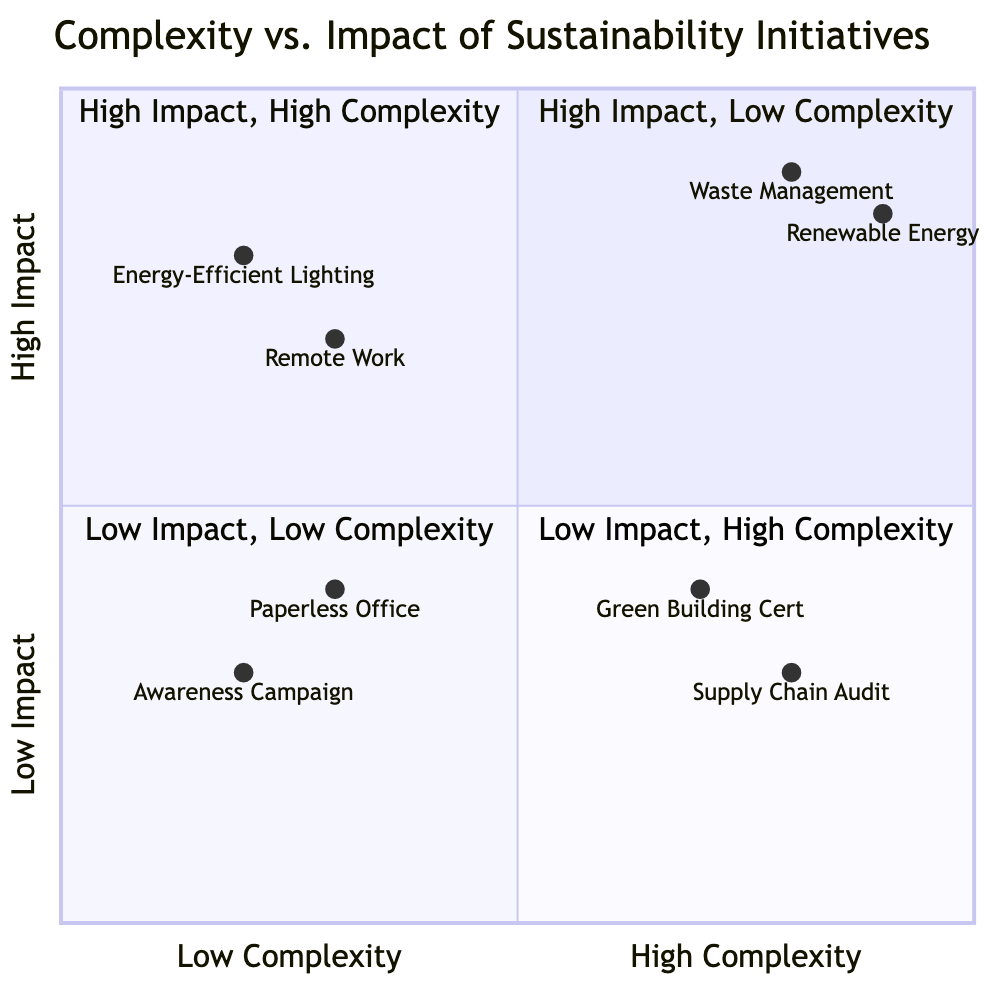What initiatives are listed in the "High Impact, Low Complexity" quadrant? The "High Impact, Low Complexity" quadrant contains the initiatives "Implementing Energy-Efficient Lighting" and "Promoting Remote Work". These are located in the upper left section of the quadrant chart, indicating high impact with low complexity.
Answer: Implementing Energy-Efficient Lighting, Promoting Remote Work How many initiatives are present in the "Low Impact, High Complexity" quadrant? There are two initiatives listed in the "Low Impact, High Complexity" quadrant, which are "Green Building Certification" and "Supply Chain Sustainability Audit". This is determined by counting the entries in that section of the diagram.
Answer: 2 What is the complexity level of "Renewable Energy Conversion"? "Renewable Energy Conversion" is located in the "High Impact, High Complexity" quadrant, indicating a high complexity level. It is placed in the upper right section of the quadrant chart.
Answer: High Which initiative has the lowest impact rating? The initiative with the lowest impact rating displayed in the quadrant chart is "Awareness Campaign". It is located in the "Low Impact, Low Complexity" quadrant, which signifies its position of both low impact and low complexity.
Answer: Awareness Campaign How does the "Comprehensive Waste Management Program" compare in complexity to the "Paperless Office Policy"? The "Comprehensive Waste Management Program" is categorized under "High Impact, High Complexity", while the "Paperless Office Policy" is classified as "Low Impact, Low Complexity". This indicates that the former has high complexity compared to the latter's low complexity.
Answer: Higher complexity Which quadrant contains the most complex initiatives? The quadrant that contains the most complex initiatives is the "High Impact, High Complexity" quadrant. This section includes initiatives such as "Comprehensive Waste Management Program" and "Renewable Energy Conversion", which are both high in complexity.
Answer: High Impact, High Complexity What is the impact rating range in the "Low Impact, Low Complexity" quadrant? The impact ratings for the initiatives in the "Low Impact, Low Complexity" quadrant are between 0.2 and 0.4, as represented by "Awareness Campaign" and "Paperless Office Policy". Therefore, the range of impact ratings is from low to low moderate.
Answer: 0.2 to 0.4 How many quadrants show initiatives that have a high impact? There are two quadrants that show initiatives with high impact: "High Impact, Low Complexity" and "High Impact, High Complexity". This can be confirmed by checking both upper sections of the diagram.
Answer: 2 Which initiative has the highest complexity rating, and what is its rating? The initiative with the highest complexity rating is the "Supply Chain Sustainability Audit", which is positioned in the "Low Impact, High Complexity" quadrant with a high complexity rating of 0.8.
Answer: Supply Chain Sustainability Audit, 0.8 